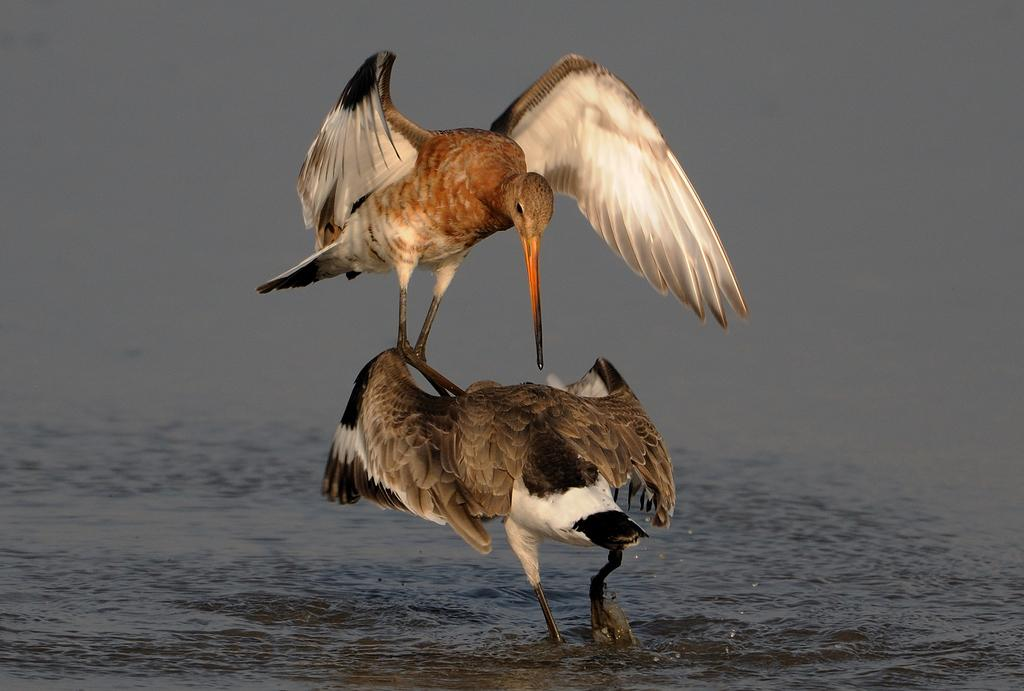What type of animals can be seen in the image? Birds can be seen in the image. What is the primary element in which the birds are situated? The birds are situated in water. What part of the natural environment is visible in the image? The sky is visible in the image. What type of jelly can be seen floating in the water in the image? There is no jelly present in the image; it features birds in the water and birds typically do not interact with jelly. 